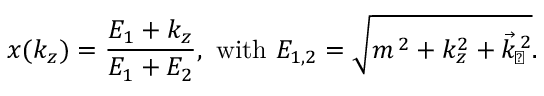<formula> <loc_0><loc_0><loc_500><loc_500>x ( k _ { z } ) = \frac { E _ { 1 } + k _ { z } } { E _ { 1 } + E _ { 2 } } , w i t h E _ { 1 , 2 } = \sqrt { m ^ { \, 2 } + k _ { z } ^ { 2 } + \vec { k } _ { \, \perp } ^ { \, 2 } } .</formula> 